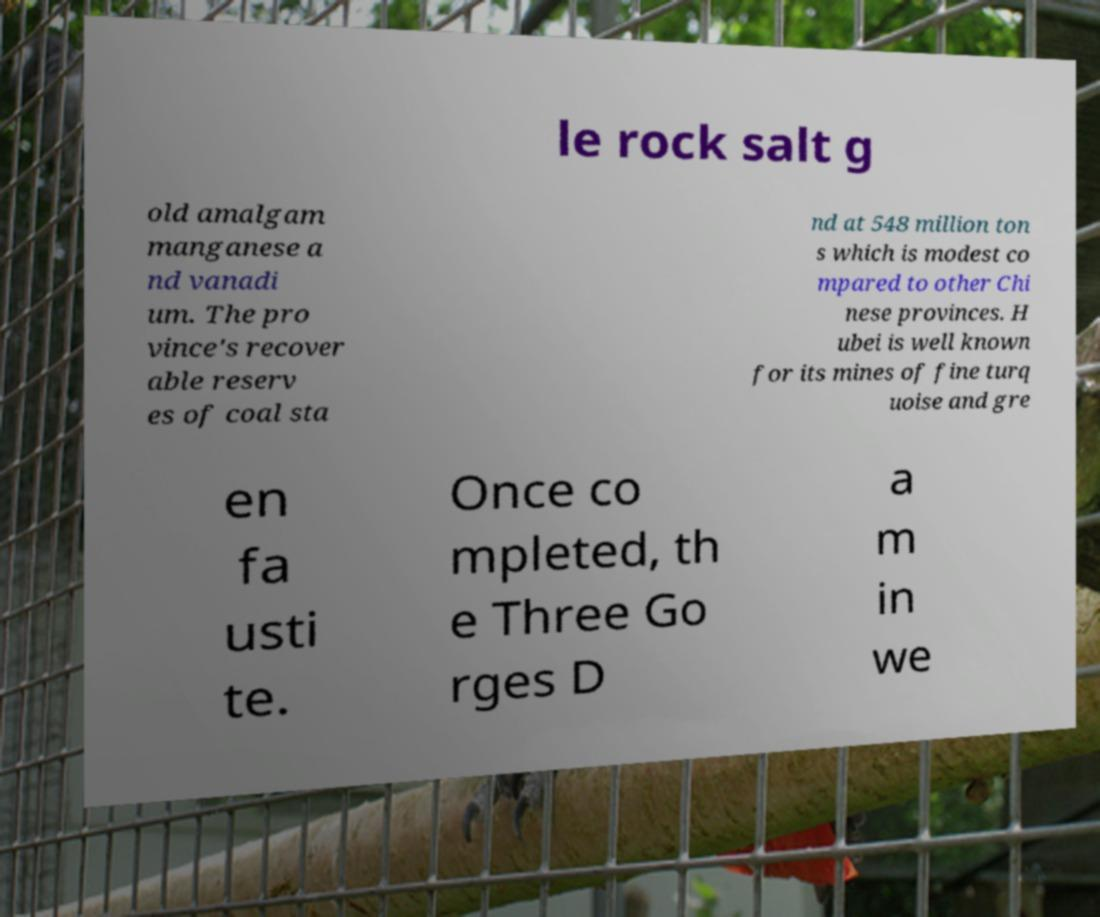What messages or text are displayed in this image? I need them in a readable, typed format. le rock salt g old amalgam manganese a nd vanadi um. The pro vince's recover able reserv es of coal sta nd at 548 million ton s which is modest co mpared to other Chi nese provinces. H ubei is well known for its mines of fine turq uoise and gre en fa usti te. Once co mpleted, th e Three Go rges D a m in we 